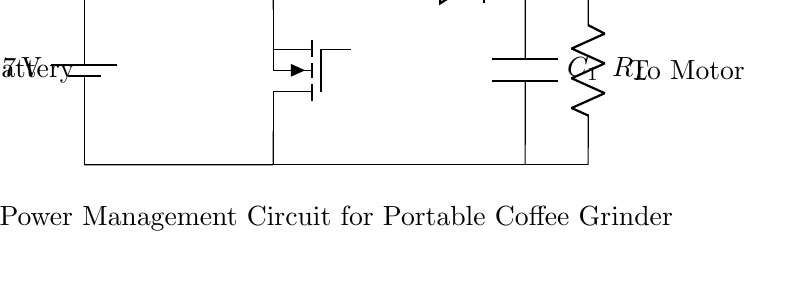What type of battery is used in this circuit? The circuit uses a lithium polymer (LiPo) battery, which is indicated in the label next to the battery symbol in the diagram.
Answer: LiPo battery What is the input voltage of the circuit? The circuit shows a battery with a voltage label of 3.7V. This is the voltage supplied to the power management circuit.
Answer: 3.7 volts What component is labeled as the boost converter? The boost converter is identified by its label in the diagram, which is placed above the inductor, indicating that this section steps up the voltage from the battery output.
Answer: Boost converter How many components are there in the output section? The output section contains two components: the resistor labeled as R_L and a connection to the motor. This is evident from the circuit layout where R_L is placed in series with the output.
Answer: Two What does the inductor in this circuit do? The inductor, labeled L_1, is used to store energy temporarily and is essential for the boost converter operation to increase the voltage from the battery before it reaches the load (motor).
Answer: Energy storage What role does the diode play in the circuit? The diode, labeled D_1, allows current to flow in one direction only, preventing backflow into the circuit and ensuring that the energy supplied to the load is not wasted or reversed.
Answer: Prevents backflow 